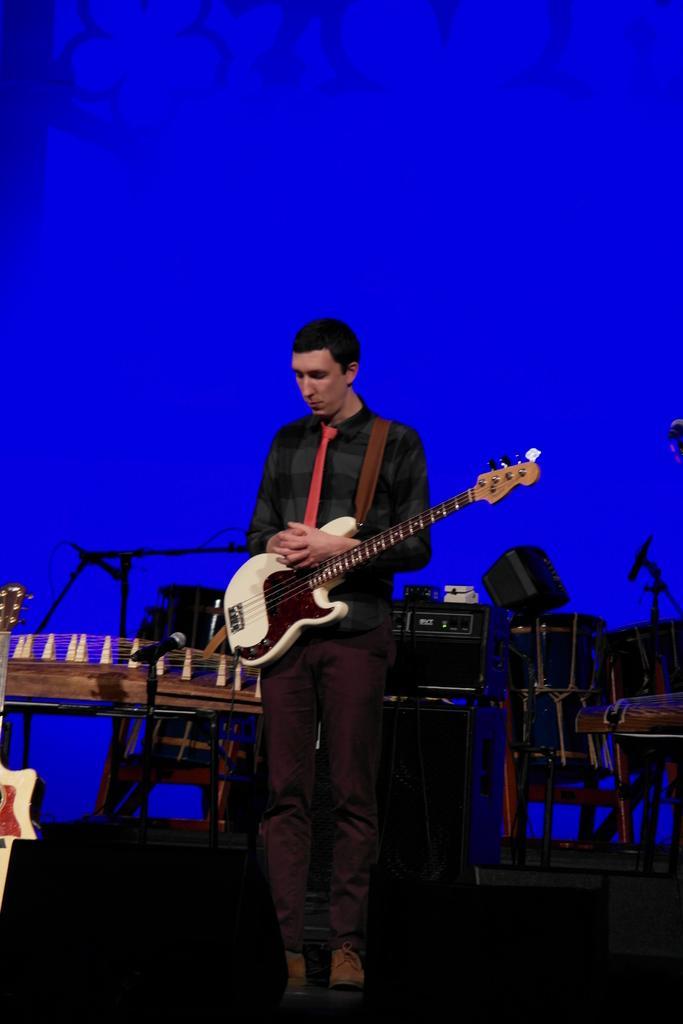How would you summarize this image in a sentence or two? In this image I can see a person holding a guitar and in the back ground I can see a wall with blue color and there are some chairs kept on the background. 